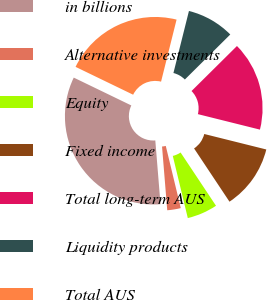Convert chart to OTSL. <chart><loc_0><loc_0><loc_500><loc_500><pie_chart><fcel>in billions<fcel>Alternative investments<fcel>Equity<fcel>Fixed income<fcel>Total long-term AUS<fcel>Liquidity products<fcel>Total AUS<nl><fcel>33.47%<fcel>2.47%<fcel>5.57%<fcel>11.77%<fcel>16.32%<fcel>8.67%<fcel>21.73%<nl></chart> 